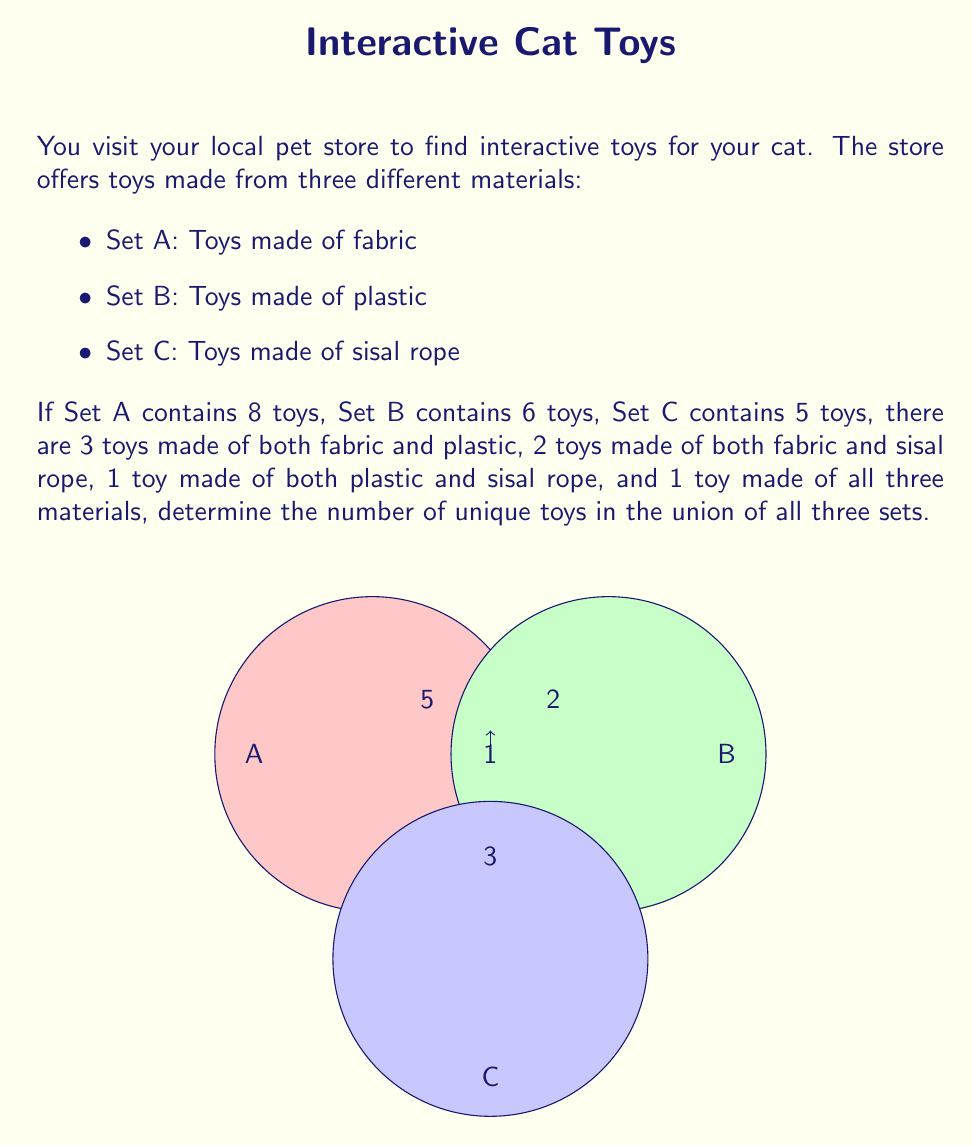Give your solution to this math problem. Let's solve this step-by-step using the principle of inclusion-exclusion:

1) First, let's define our universe:
   $U = A \cup B \cup C$

2) The principle of inclusion-exclusion states:
   $$|A \cup B \cup C| = |A| + |B| + |C| - |A \cap B| - |A \cap C| - |B \cap C| + |A \cap B \cap C|$$

3) We're given:
   $|A| = 8$
   $|B| = 6$
   $|C| = 5$
   $|A \cap B| = 3$
   $|A \cap C| = 2$
   $|B \cap C| = 1$
   $|A \cap B \cap C| = 1$

4) Now, let's substitute these values into our equation:
   $$|U| = 8 + 6 + 5 - 3 - 2 - 1 + 1$$

5) Simplifying:
   $$|U| = 19 - 6 + 1 = 14$$

Therefore, the union of all three sets contains 14 unique toys.
Answer: 14 